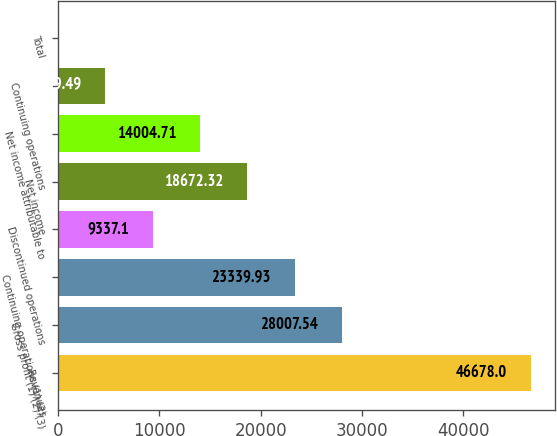Convert chart. <chart><loc_0><loc_0><loc_500><loc_500><bar_chart><fcel>Revenues<fcel>Gross profit (1) (2) (3)<fcel>Continuing operations (1) (2)<fcel>Discontinued operations<fcel>Net income<fcel>Net income attributable to<fcel>Continuing operations<fcel>Total<nl><fcel>46678<fcel>28007.5<fcel>23339.9<fcel>9337.1<fcel>18672.3<fcel>14004.7<fcel>4669.49<fcel>1.88<nl></chart> 